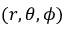Convert formula to latex. <formula><loc_0><loc_0><loc_500><loc_500>( r , \theta , \phi )</formula> 